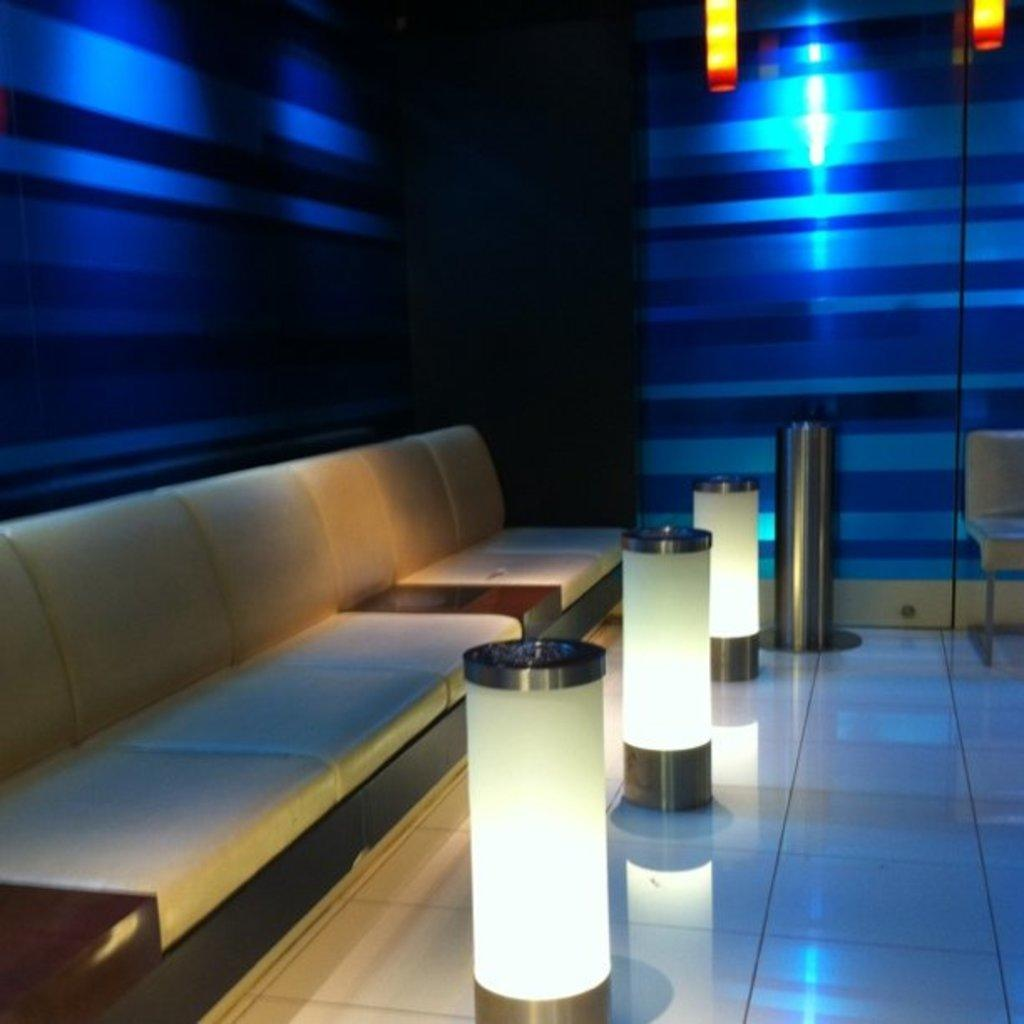What type of furniture is present in the image? There is a couch in the image. What can be seen illuminating the area in the image? There are lights visible in the image. How many hens are sitting on the couch in the image? There are no hens present in the image; it only features a couch and lights. What type of wealth is depicted in the image? There is no depiction of wealth in the image; it only features a couch and lights. 